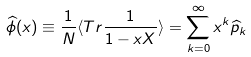Convert formula to latex. <formula><loc_0><loc_0><loc_500><loc_500>\widehat { \phi } ( x ) \equiv \frac { 1 } { N } \langle T r \frac { 1 } { 1 - x X } \rangle = \sum _ { k = 0 } ^ { \infty } x ^ { k } \widehat { p } _ { k }</formula> 